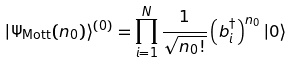Convert formula to latex. <formula><loc_0><loc_0><loc_500><loc_500>| \Psi _ { \text {Mott} } ( n _ { 0 } ) \rangle ^ { ( 0 ) } = \prod _ { i = 1 } ^ { N } \frac { 1 } { \sqrt { n _ { 0 } ! } } \left ( b ^ { \dagger } _ { i } \right ) ^ { n _ { 0 } } | 0 \rangle</formula> 